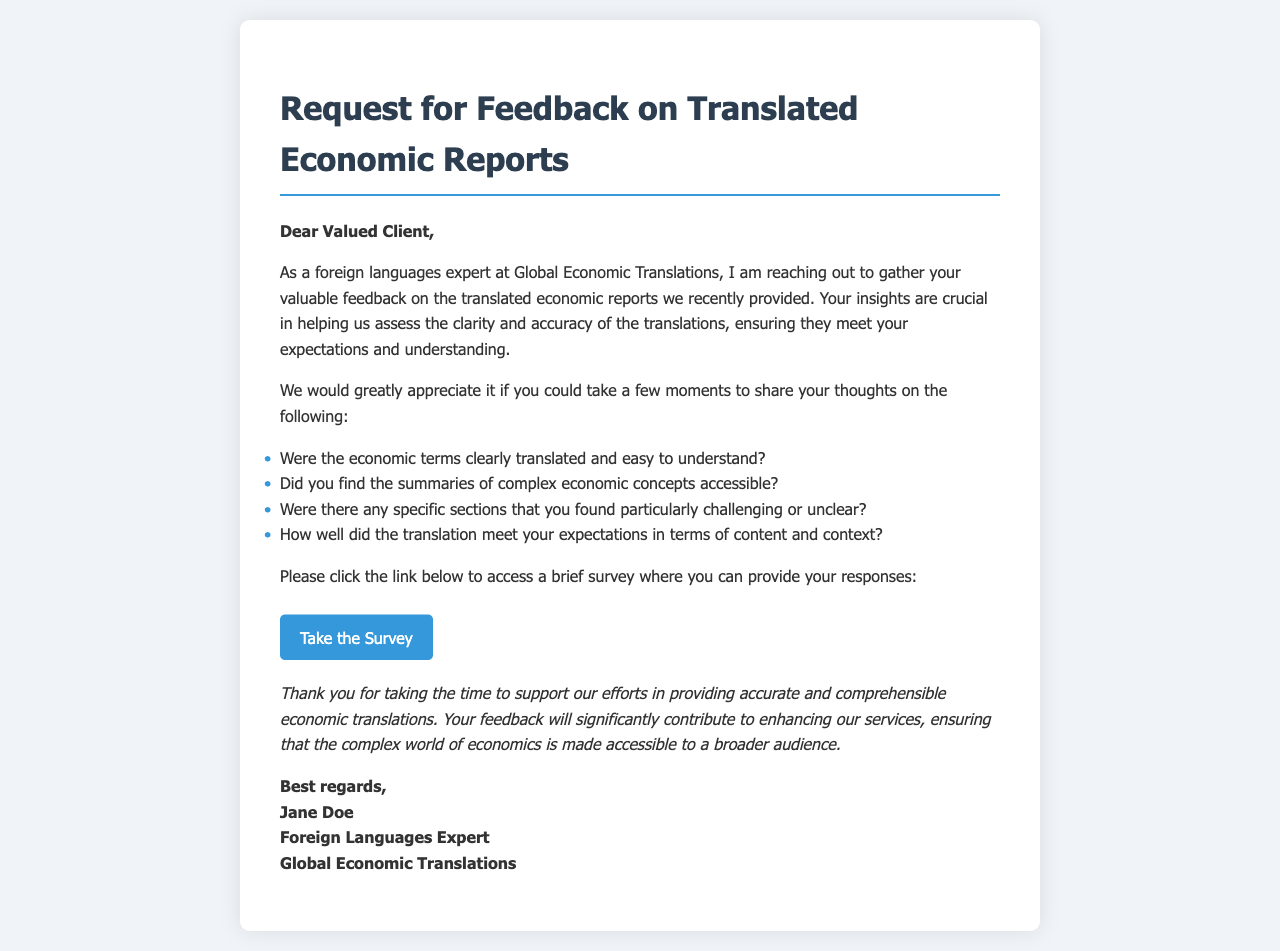What is the title of the letter? The title of the letter is found in the heading at the top of the document.
Answer: Request for Feedback on Translated Economic Reports Who is the sender of the letter? The sender's name and position are found in the closing section of the letter.
Answer: Jane Doe What is the main purpose of the letter? The main purpose is described in the opening paragraph.
Answer: Gather feedback What is the survey link provided in the letter? The survey link is mentioned explicitly in the survey section.
Answer: https://www.surveymonkey.com/r/EconReportFeedback What company is the sender associated with? The company name is mentioned in the signature at the end of the letter.
Answer: Global Economic Translations Which section of the letter addresses clarity of economic terms? Clarity of economic terms is addressed in the list of feedback questions.
Answer: Were the economic terms clearly translated and easy to understand? What type of document is this? The structure and purpose define the type of document.
Answer: Feedback request letter How many questions are asked for feedback? The number of feedback questions is specific to the listed items in the document.
Answer: Four questions What is the tone of the letter? The tone can be inferred from the language used throughout the document.
Answer: Professional and courteous 